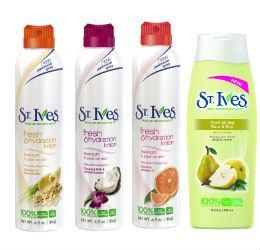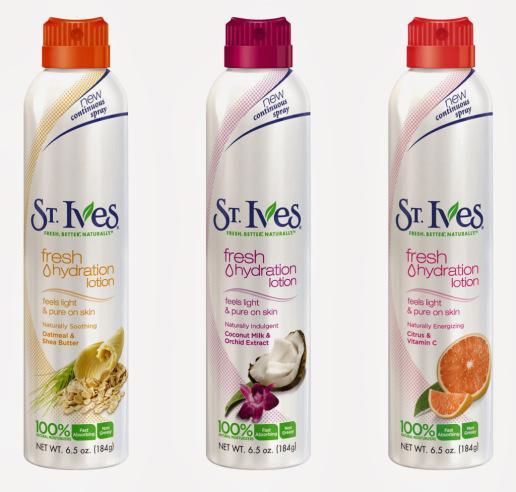The first image is the image on the left, the second image is the image on the right. For the images shown, is this caption "there are 7 beauty products in the image pair" true? Answer yes or no. Yes. The first image is the image on the left, the second image is the image on the right. Analyze the images presented: Is the assertion "The image on the left has one bottle of St. Ives Fresh Hydration Lotion in front of objects that match the objects on the bottle." valid? Answer yes or no. No. 